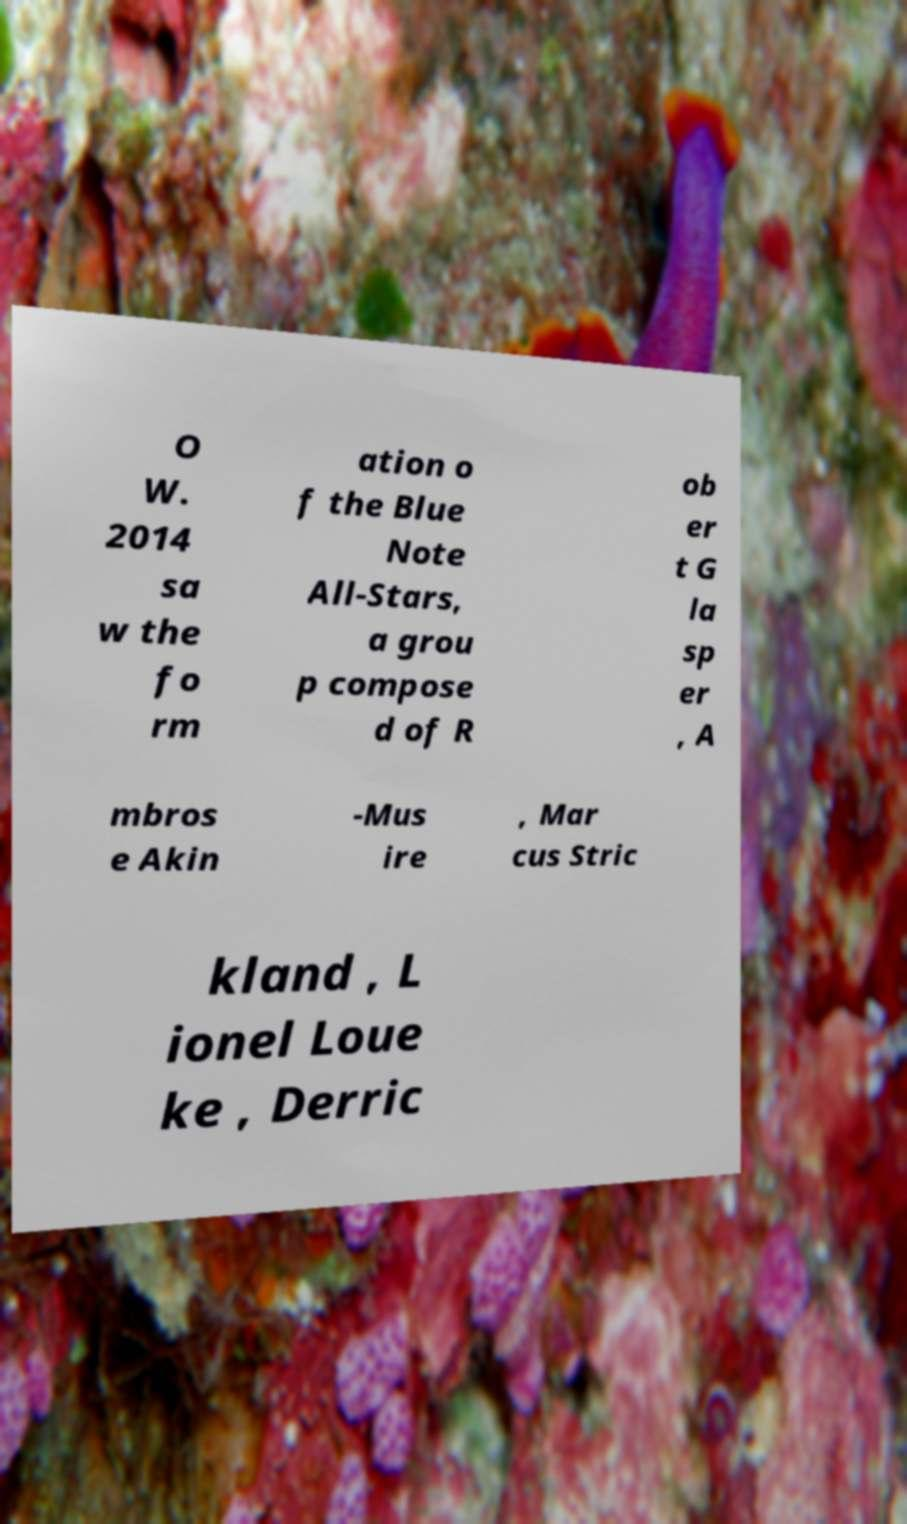There's text embedded in this image that I need extracted. Can you transcribe it verbatim? O W. 2014 sa w the fo rm ation o f the Blue Note All-Stars, a grou p compose d of R ob er t G la sp er , A mbros e Akin -Mus ire , Mar cus Stric kland , L ionel Loue ke , Derric 